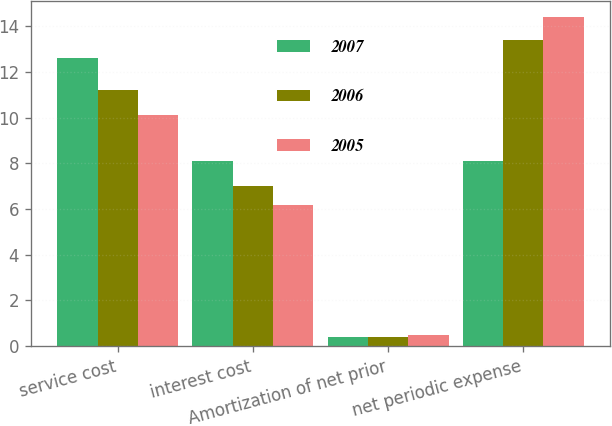Convert chart. <chart><loc_0><loc_0><loc_500><loc_500><stacked_bar_chart><ecel><fcel>service cost<fcel>interest cost<fcel>Amortization of net prior<fcel>net periodic expense<nl><fcel>2007<fcel>12.6<fcel>8.1<fcel>0.4<fcel>8.1<nl><fcel>2006<fcel>11.2<fcel>7<fcel>0.4<fcel>13.4<nl><fcel>2005<fcel>10.1<fcel>6.2<fcel>0.5<fcel>14.4<nl></chart> 